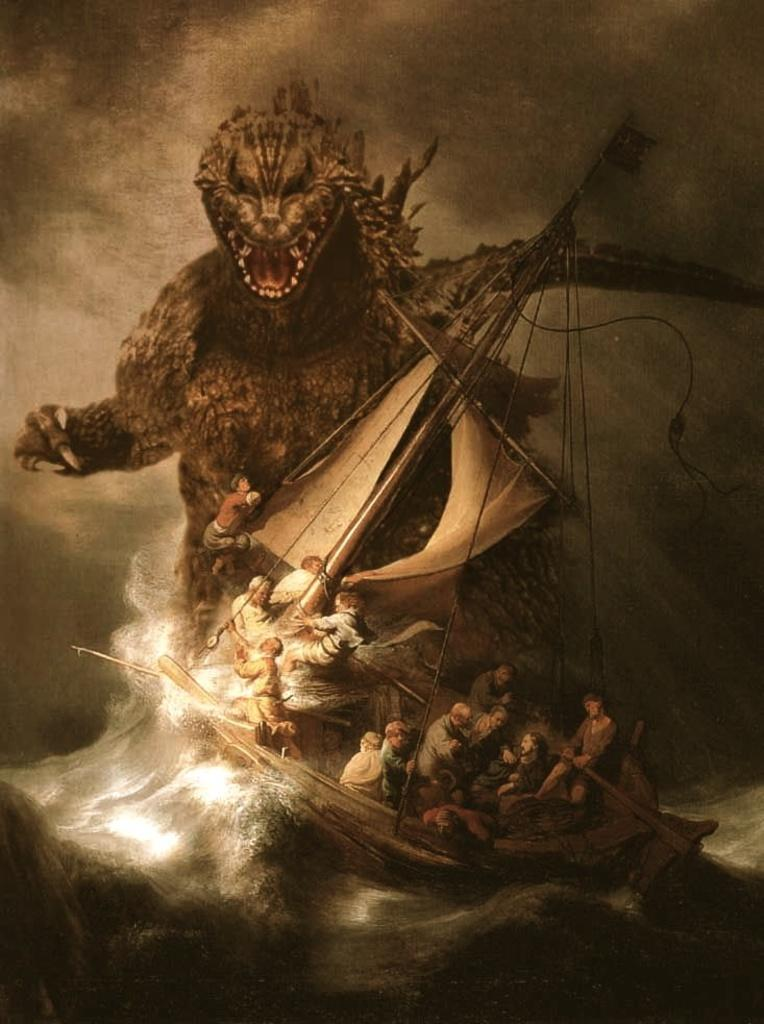What type of image is shown in the picture? The image contains a graphical representation. What can be seen at the bottom of the image? There is water at the bottom of the image. What is floating on the water in the image? There is a boat in the image. Who is in the boat? There are people in the boat. Can you tell me how many frogs are sitting on the boat in the image? There are no frogs present in the image; it features a boat with people in it. What type of humor can be seen in the image? There is no humor depicted in the image; it is a straightforward representation of a boat with people in it. 